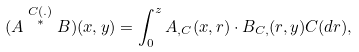<formula> <loc_0><loc_0><loc_500><loc_500>( A \stackrel { C ( . ) } { ^ { * } } B ) ( x , y ) = \int _ { 0 } ^ { z } A _ { , C } ( x , r ) \cdot B _ { C , } ( r , y ) C ( d r ) ,</formula> 